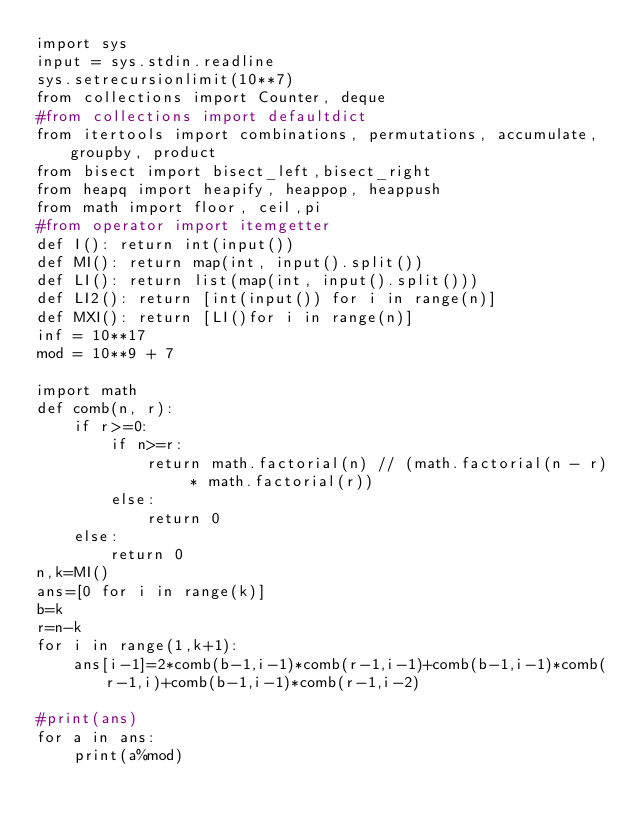<code> <loc_0><loc_0><loc_500><loc_500><_Python_>import sys
input = sys.stdin.readline
sys.setrecursionlimit(10**7)
from collections import Counter, deque
#from collections import defaultdict
from itertools import combinations, permutations, accumulate, groupby, product
from bisect import bisect_left,bisect_right
from heapq import heapify, heappop, heappush
from math import floor, ceil,pi
#from operator import itemgetter
def I(): return int(input())
def MI(): return map(int, input().split())
def LI(): return list(map(int, input().split()))
def LI2(): return [int(input()) for i in range(n)]
def MXI(): return [LI()for i in range(n)]
inf = 10**17
mod = 10**9 + 7

import math
def comb(n, r):
    if r>=0:
        if n>=r:
            return math.factorial(n) // (math.factorial(n - r) * math.factorial(r))
        else:
            return 0
    else:
        return 0
n,k=MI()
ans=[0 for i in range(k)]
b=k
r=n-k
for i in range(1,k+1):
    ans[i-1]=2*comb(b-1,i-1)*comb(r-1,i-1)+comb(b-1,i-1)*comb(r-1,i)+comb(b-1,i-1)*comb(r-1,i-2)

#print(ans)
for a in ans:
    print(a%mod)



    

        
    
    
    

    
    

</code> 